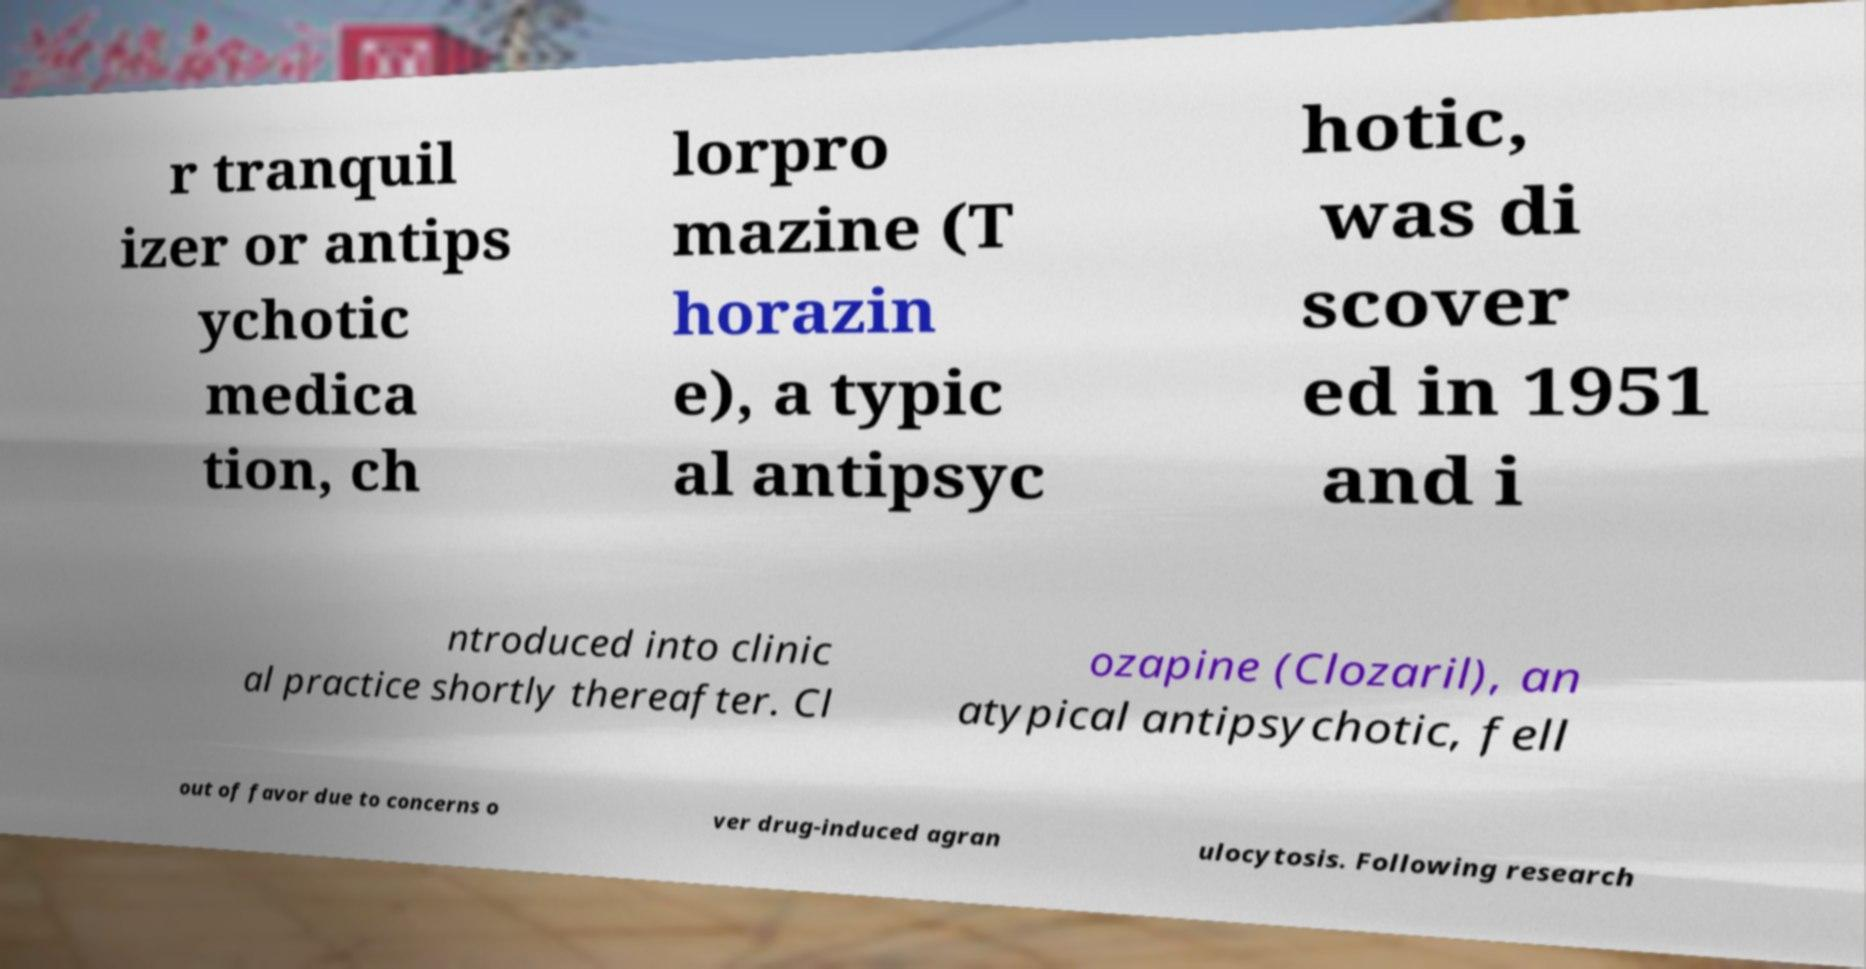Could you extract and type out the text from this image? r tranquil izer or antips ychotic medica tion, ch lorpro mazine (T horazin e), a typic al antipsyc hotic, was di scover ed in 1951 and i ntroduced into clinic al practice shortly thereafter. Cl ozapine (Clozaril), an atypical antipsychotic, fell out of favor due to concerns o ver drug-induced agran ulocytosis. Following research 